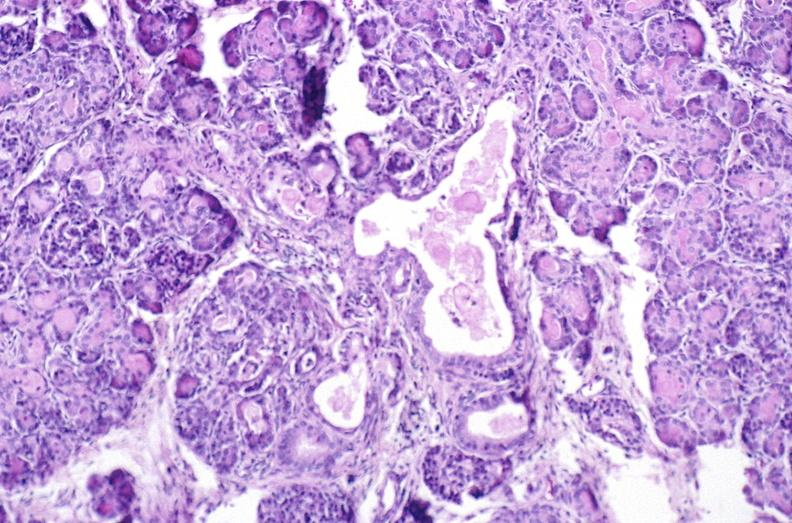what does this image show?
Answer the question using a single word or phrase. Cystic fibrosis 